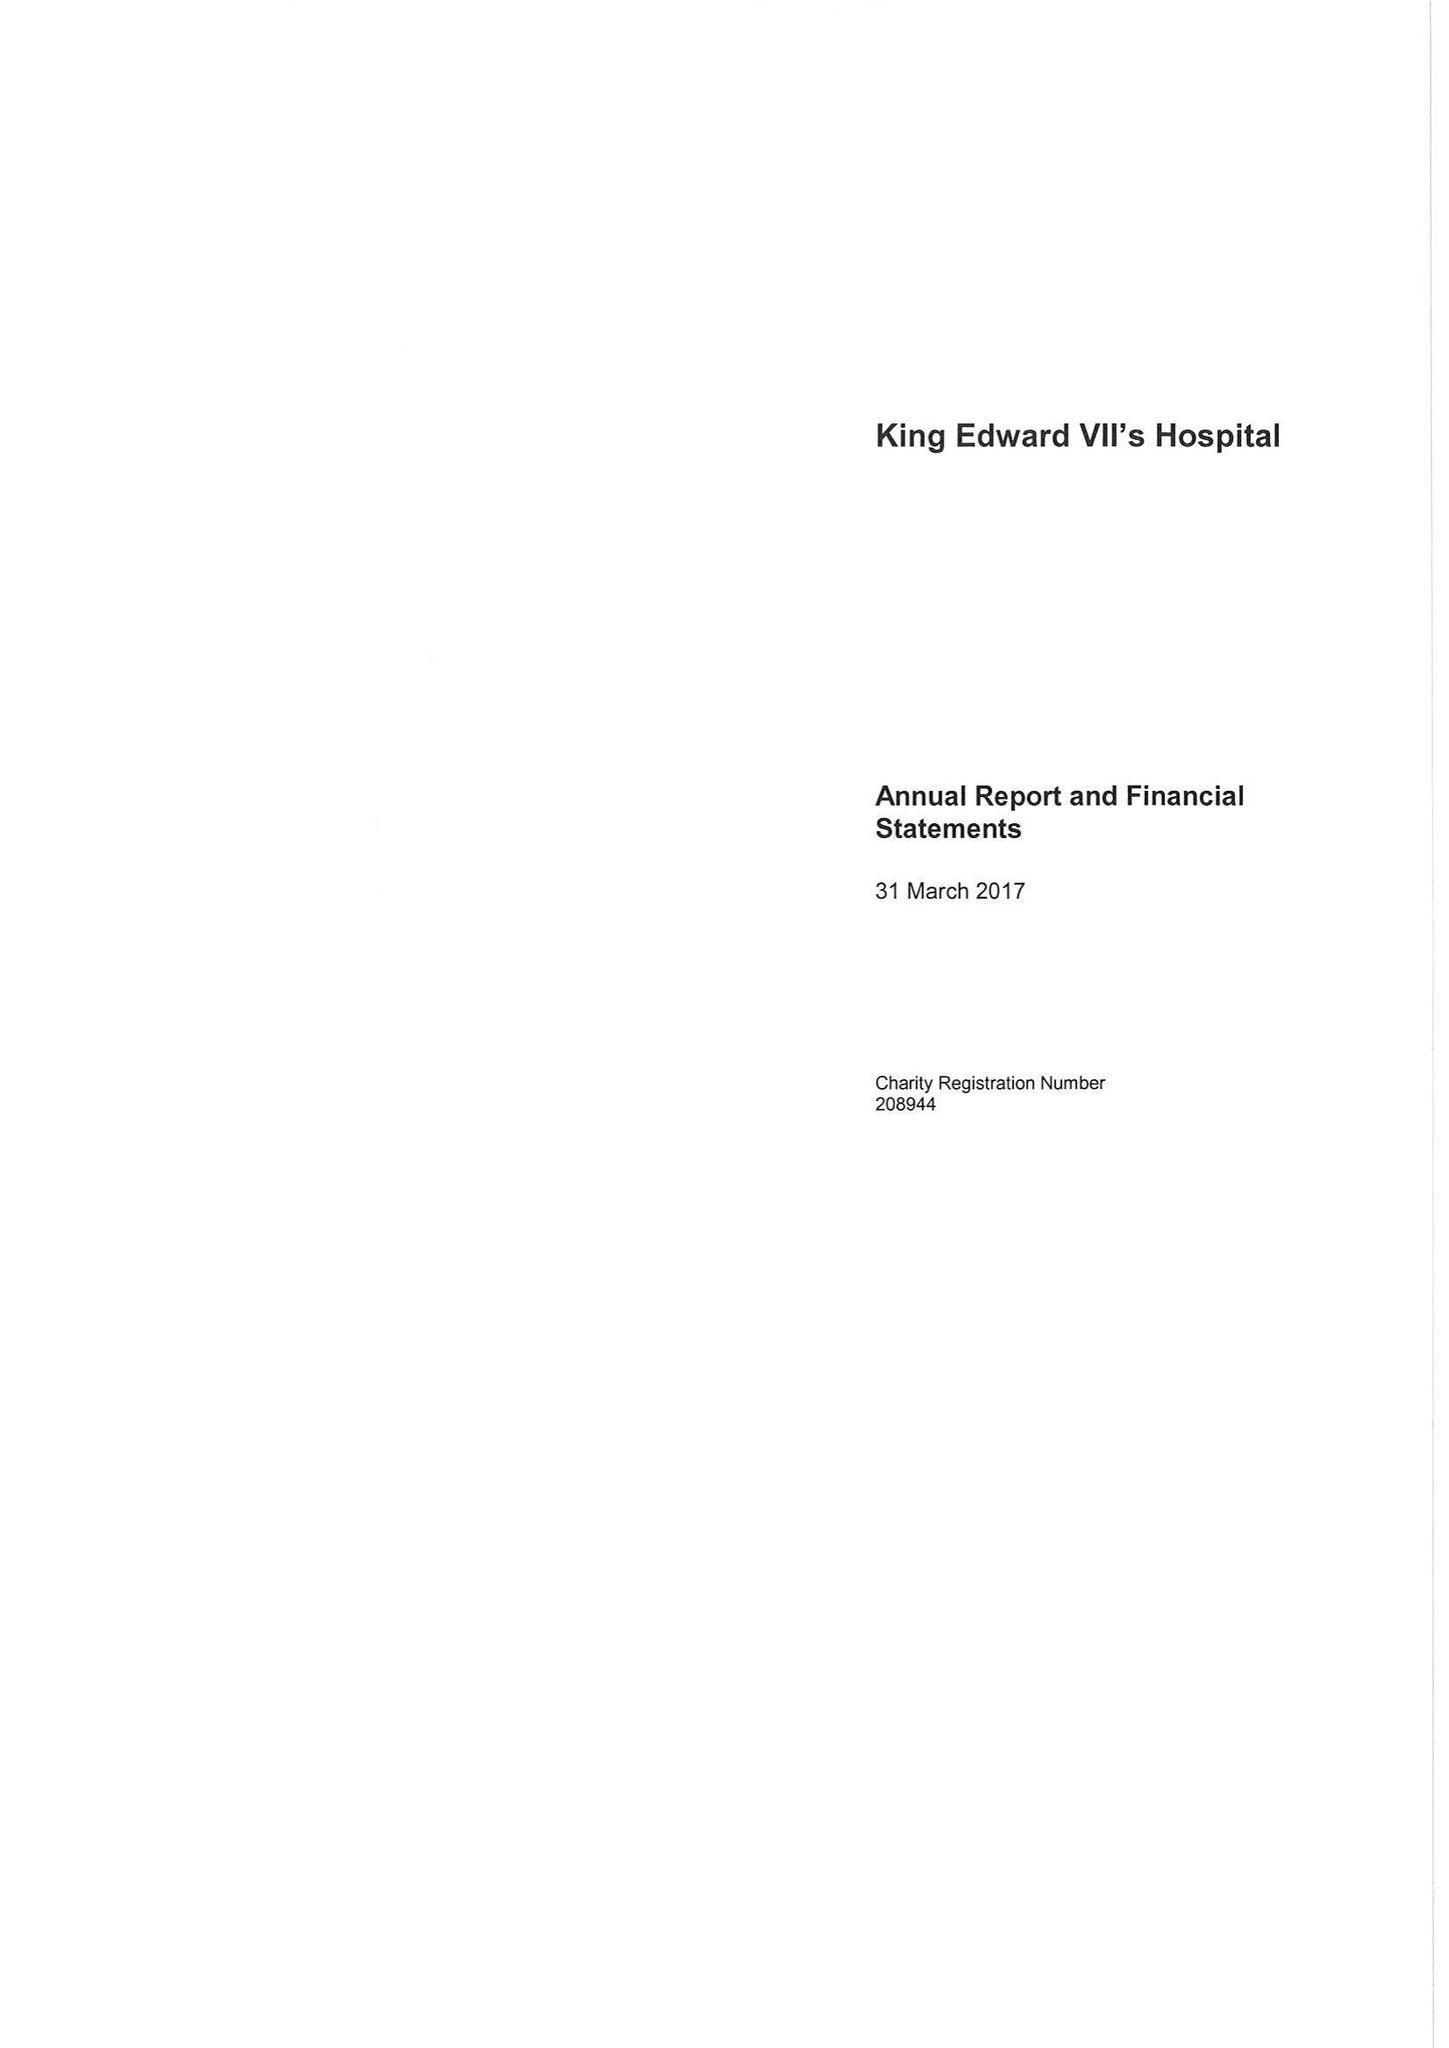What is the value for the address__postcode?
Answer the question using a single word or phrase. W1G 6AA 